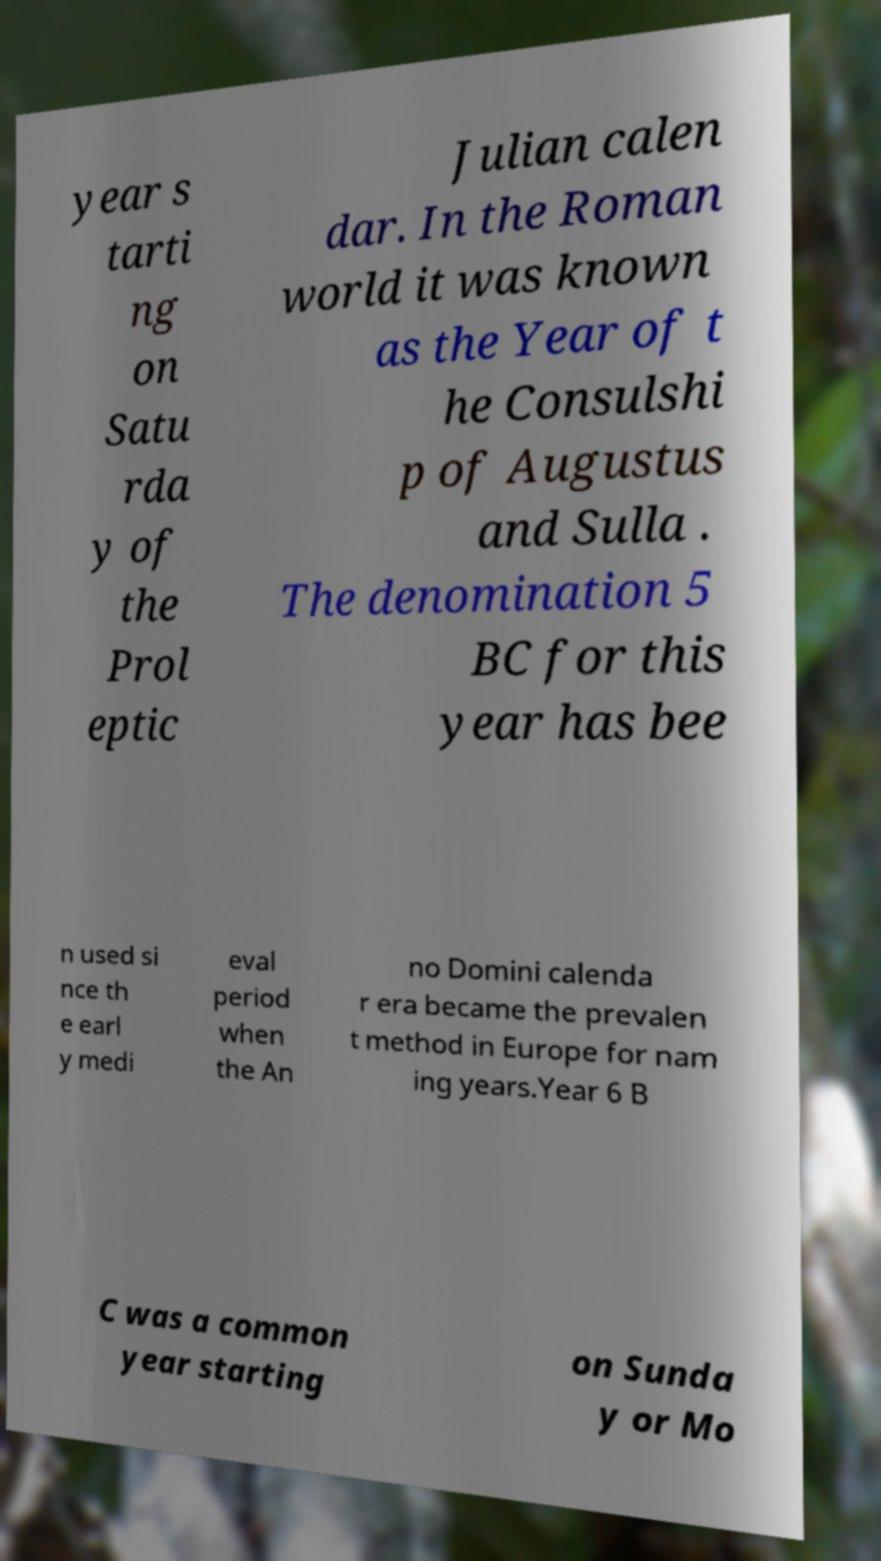Can you read and provide the text displayed in the image?This photo seems to have some interesting text. Can you extract and type it out for me? year s tarti ng on Satu rda y of the Prol eptic Julian calen dar. In the Roman world it was known as the Year of t he Consulshi p of Augustus and Sulla . The denomination 5 BC for this year has bee n used si nce th e earl y medi eval period when the An no Domini calenda r era became the prevalen t method in Europe for nam ing years.Year 6 B C was a common year starting on Sunda y or Mo 